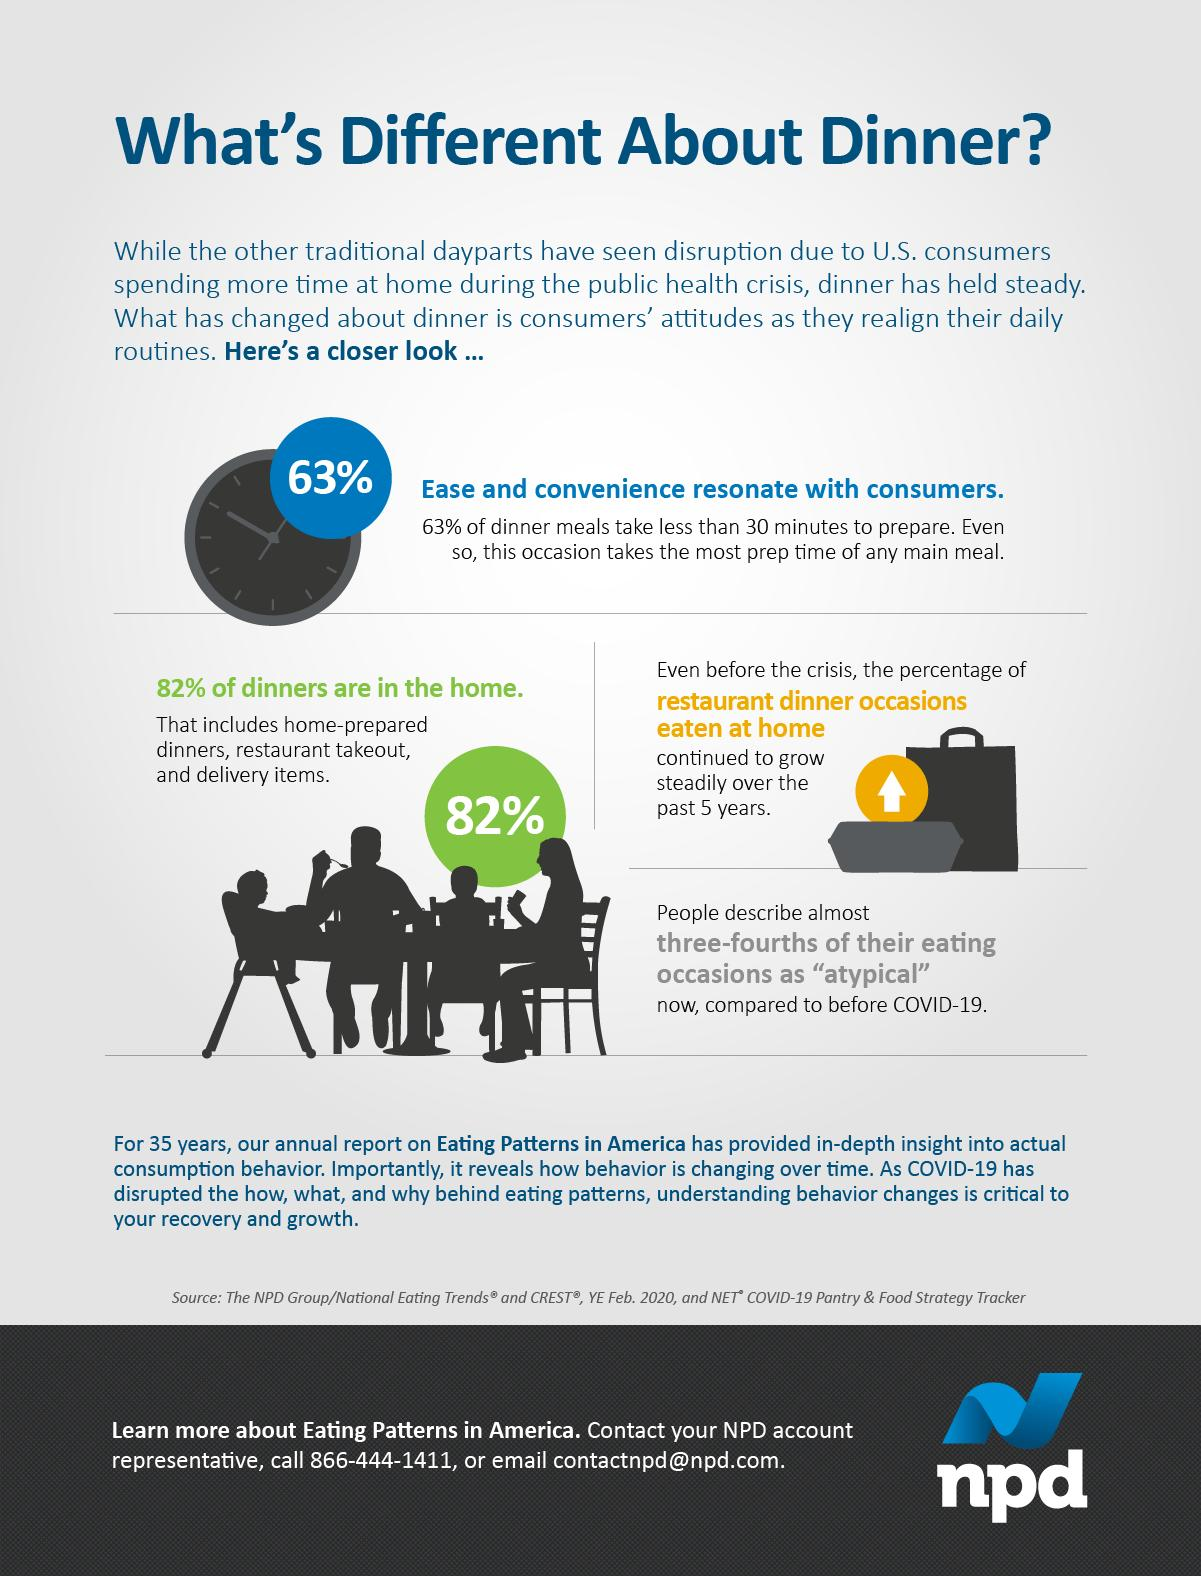Mention a couple of crucial points in this snapshot. Home-prepared dinners, restaurant takeout, and delivery items are all included in the category of dinners consumed at home. Dinner takes the most preparation time of any meal. In the past five years, the trend of dining at home rather than eating out at restaurants has steadily increased. A dinner meal that can be prepared in less than half an hour is now available for your pleasure. 